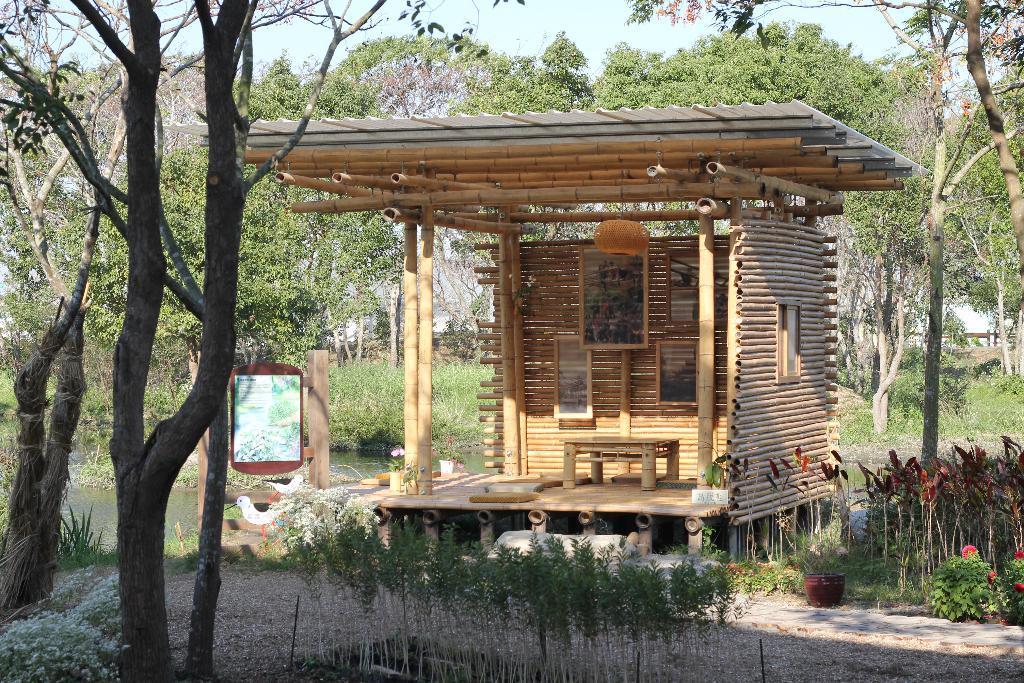In one or two sentences, can you explain what this image depicts? In this image we can see a wooden shed. Behind the shed we can see a group of trees, plants and water. In front of the shed there are group of trees and plants. At the top we can see the sky. 